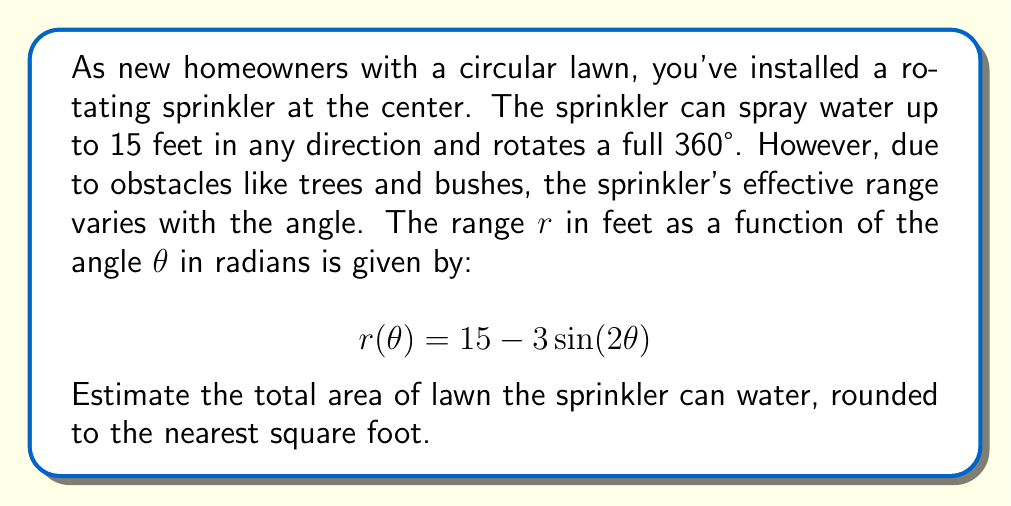Can you answer this question? To solve this problem, we need to use the formula for area in polar coordinates and integrate over the full rotation of the sprinkler. Here's a step-by-step approach:

1) The formula for area in polar coordinates is:

   $$A = \frac{1}{2} \int_a^b [r(\theta)]^2 d\theta$$

   where $a$ and $b$ are the starting and ending angles of the region.

2) In this case, we're considering the full 360° rotation, so $a = 0$ and $b = 2\pi$.

3) We need to square our given function $r(\theta) = 15 - 3\sin(2\theta)$:

   $$[r(\theta)]^2 = (15 - 3\sin(2\theta))^2 = 225 - 90\sin(2\theta) + 9\sin^2(2\theta)$$

4) Now we can set up our integral:

   $$A = \frac{1}{2} \int_0^{2\pi} (225 - 90\sin(2\theta) + 9\sin^2(2\theta)) d\theta$$

5) Let's integrate each term separately:
   
   - $\int_0^{2\pi} 225 d\theta = 225\theta \big|_0^{2\pi} = 450\pi$
   
   - $\int_0^{2\pi} -90\sin(2\theta) d\theta = 45\cos(2\theta) \big|_0^{2\pi} = 0$
   
   - $\int_0^{2\pi} 9\sin^2(2\theta) d\theta = \frac{9}{2}\theta - \frac{9}{4}\sin(4\theta) \big|_0^{2\pi} = 9\pi$

6) Adding these results and multiplying by $\frac{1}{2}$:

   $$A = \frac{1}{2}(450\pi + 0 + 9\pi) = \frac{459\pi}{2} \approx 720.76 \text{ sq ft}$$

7) Rounding to the nearest square foot gives us 721 sq ft.
Answer: 721 square feet 